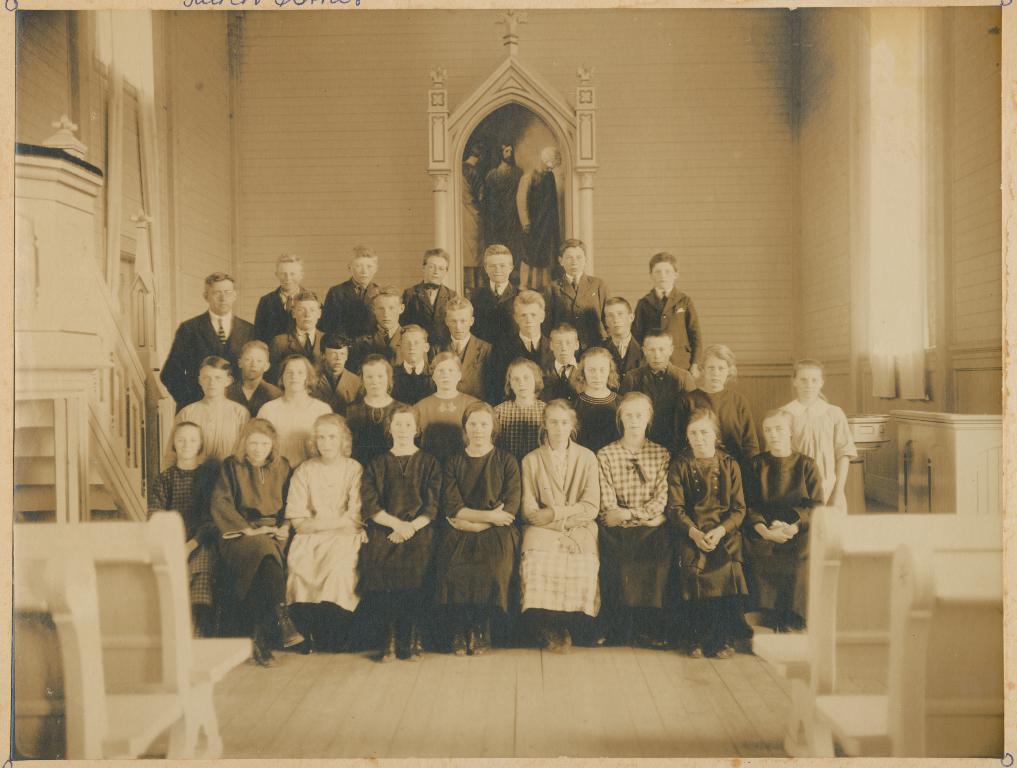Please provide a concise description of this image. In this image there are many people inside a room. On the wall there is a painting. On both sides there are benches. These are windows with curtains. 